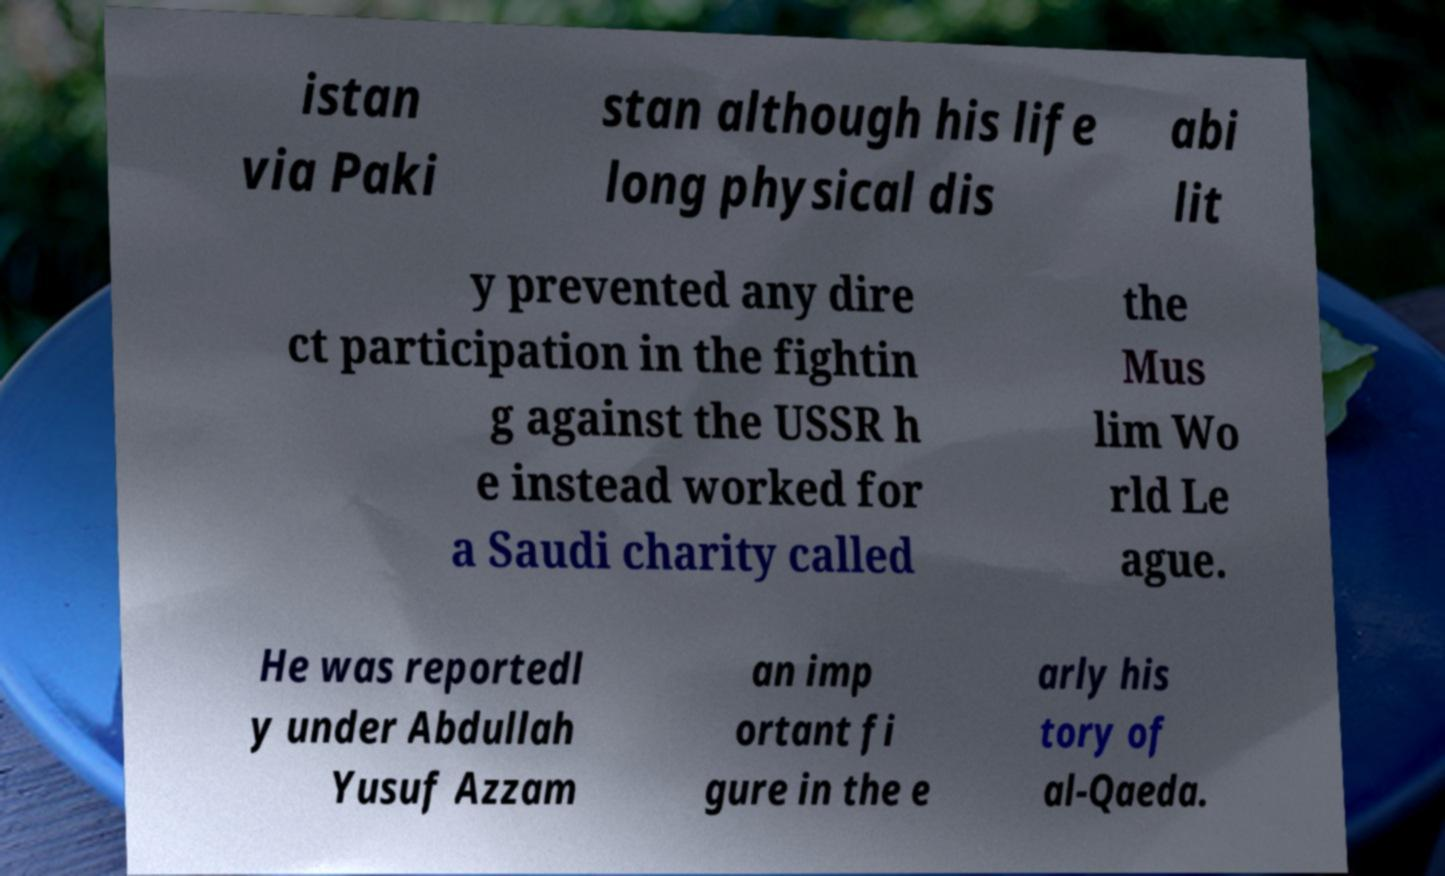There's text embedded in this image that I need extracted. Can you transcribe it verbatim? istan via Paki stan although his life long physical dis abi lit y prevented any dire ct participation in the fightin g against the USSR h e instead worked for a Saudi charity called the Mus lim Wo rld Le ague. He was reportedl y under Abdullah Yusuf Azzam an imp ortant fi gure in the e arly his tory of al-Qaeda. 